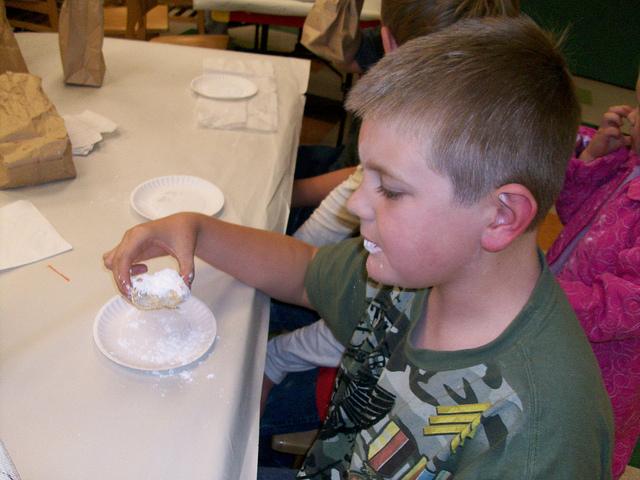What are the plates made of?
Write a very short answer. Paper. How many plates are on the table?
Quick response, please. 3. Is someone wearing sunglasses on the top of their head?
Concise answer only. No. Is there chocolate on the plate?
Be succinct. No. Is the child falling asleep?
Short answer required. No. What flavor is the cake?
Concise answer only. Vanilla. What is the boy holding in his hand?
Be succinct. Cake. What is covering the boy's mouth?
Be succinct. Sugar. What color is the table cover?
Give a very brief answer. White. What is the person eating?
Keep it brief. Donut. What is the kid cutting?
Concise answer only. Cake. What is the child holding in his left hand?
Concise answer only. Nothing. Where is the cupcake?
Be succinct. Boy's hand. What character is on the kid's shirt?
Be succinct. Gi joe. What color is this boys hair?
Answer briefly. Blonde. 